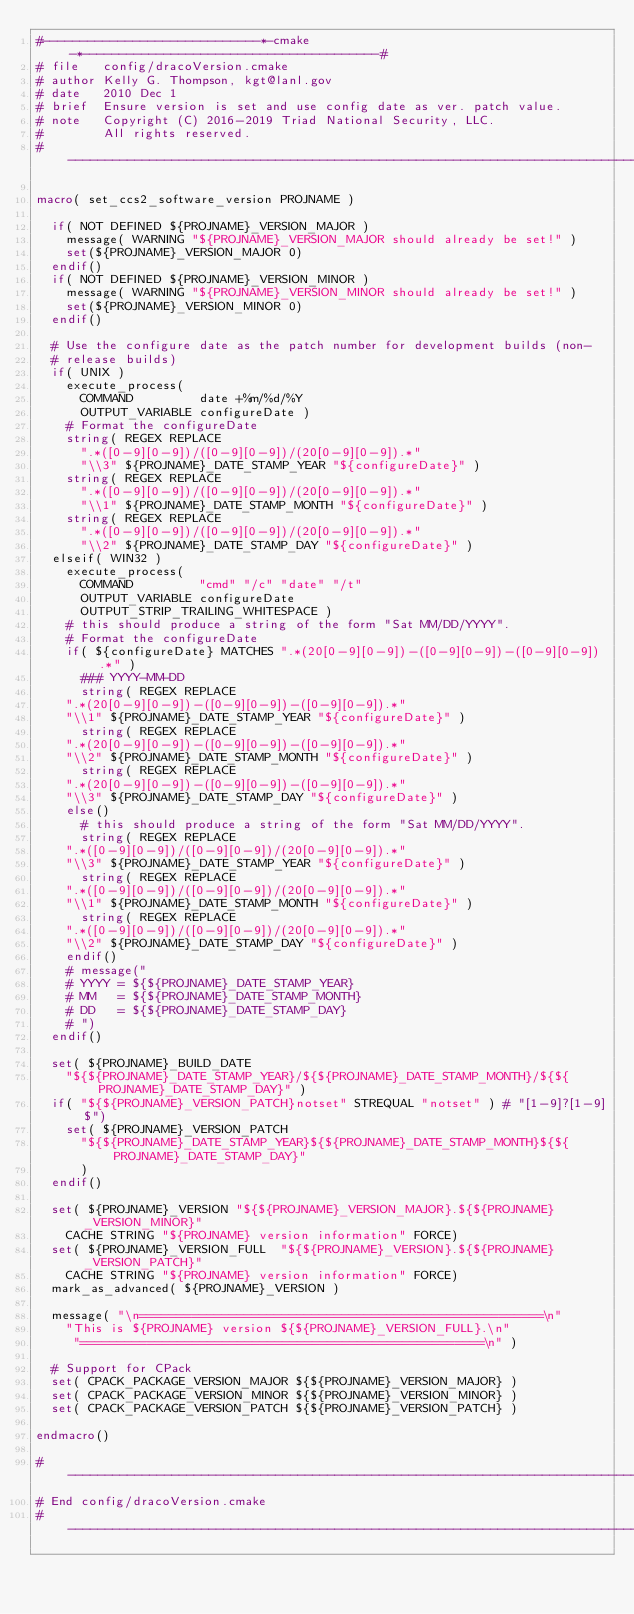Convert code to text. <code><loc_0><loc_0><loc_500><loc_500><_CMake_>#-----------------------------*-cmake-*----------------------------------------#
# file   config/dracoVersion.cmake
# author Kelly G. Thompson, kgt@lanl.gov
# date   2010 Dec 1
# brief  Ensure version is set and use config date as ver. patch value.
# note   Copyright (C) 2016-2019 Triad National Security, LLC.
#        All rights reserved.
#------------------------------------------------------------------------------#

macro( set_ccs2_software_version PROJNAME )

  if( NOT DEFINED ${PROJNAME}_VERSION_MAJOR )
    message( WARNING "${PROJNAME}_VERSION_MAJOR should already be set!" )
    set(${PROJNAME}_VERSION_MAJOR 0)
  endif()
  if( NOT DEFINED ${PROJNAME}_VERSION_MINOR )
    message( WARNING "${PROJNAME}_VERSION_MINOR should already be set!" )
    set(${PROJNAME}_VERSION_MINOR 0)
  endif()

  # Use the configure date as the patch number for development builds (non-
  # release builds)
  if( UNIX )
    execute_process(
      COMMAND         date +%m/%d/%Y
      OUTPUT_VARIABLE configureDate )
    # Format the configureDate
    string( REGEX REPLACE
      ".*([0-9][0-9])/([0-9][0-9])/(20[0-9][0-9]).*"
      "\\3" ${PROJNAME}_DATE_STAMP_YEAR "${configureDate}" )
    string( REGEX REPLACE
      ".*([0-9][0-9])/([0-9][0-9])/(20[0-9][0-9]).*"
      "\\1" ${PROJNAME}_DATE_STAMP_MONTH "${configureDate}" )
    string( REGEX REPLACE
      ".*([0-9][0-9])/([0-9][0-9])/(20[0-9][0-9]).*"
      "\\2" ${PROJNAME}_DATE_STAMP_DAY "${configureDate}" )
  elseif( WIN32 )
    execute_process(
      COMMAND         "cmd" "/c" "date" "/t"
      OUTPUT_VARIABLE configureDate
      OUTPUT_STRIP_TRAILING_WHITESPACE )
    # this should produce a string of the form "Sat MM/DD/YYYY".
    # Format the configureDate
    if( ${configureDate} MATCHES ".*(20[0-9][0-9])-([0-9][0-9])-([0-9][0-9]).*" )
      ### YYYY-MM-DD
      string( REGEX REPLACE
	".*(20[0-9][0-9])-([0-9][0-9])-([0-9][0-9]).*"
	"\\1" ${PROJNAME}_DATE_STAMP_YEAR "${configureDate}" )
      string( REGEX REPLACE
	".*(20[0-9][0-9])-([0-9][0-9])-([0-9][0-9]).*"
	"\\2" ${PROJNAME}_DATE_STAMP_MONTH "${configureDate}" )
      string( REGEX REPLACE
	".*(20[0-9][0-9])-([0-9][0-9])-([0-9][0-9]).*"
	"\\3" ${PROJNAME}_DATE_STAMP_DAY "${configureDate}" )
    else()
      # this should produce a string of the form "Sat MM/DD/YYYY".
      string( REGEX REPLACE
	".*([0-9][0-9])/([0-9][0-9])/(20[0-9][0-9]).*"
	"\\3" ${PROJNAME}_DATE_STAMP_YEAR "${configureDate}" )
      string( REGEX REPLACE
	".*([0-9][0-9])/([0-9][0-9])/(20[0-9][0-9]).*"
	"\\1" ${PROJNAME}_DATE_STAMP_MONTH "${configureDate}" )
      string( REGEX REPLACE
	".*([0-9][0-9])/([0-9][0-9])/(20[0-9][0-9]).*"
	"\\2" ${PROJNAME}_DATE_STAMP_DAY "${configureDate}" )
    endif()
    # message("
    # YYYY = ${${PROJNAME}_DATE_STAMP_YEAR}
    # MM   = ${${PROJNAME}_DATE_STAMP_MONTH}
    # DD   = ${${PROJNAME}_DATE_STAMP_DAY}
    # ")
  endif()

  set( ${PROJNAME}_BUILD_DATE
    "${${PROJNAME}_DATE_STAMP_YEAR}/${${PROJNAME}_DATE_STAMP_MONTH}/${${PROJNAME}_DATE_STAMP_DAY}" )
  if( "${${PROJNAME}_VERSION_PATCH}notset" STREQUAL "notset" ) # "[1-9]?[1-9]$")
    set( ${PROJNAME}_VERSION_PATCH
      "${${PROJNAME}_DATE_STAMP_YEAR}${${PROJNAME}_DATE_STAMP_MONTH}${${PROJNAME}_DATE_STAMP_DAY}"
      )
  endif()

  set( ${PROJNAME}_VERSION "${${PROJNAME}_VERSION_MAJOR}.${${PROJNAME}_VERSION_MINOR}"
    CACHE STRING "${PROJNAME} version information" FORCE)
  set( ${PROJNAME}_VERSION_FULL  "${${PROJNAME}_VERSION}.${${PROJNAME}_VERSION_PATCH}"
    CACHE STRING "${PROJNAME} version information" FORCE)
  mark_as_advanced( ${PROJNAME}_VERSION )

  message( "\n======================================================\n"
    "This is ${PROJNAME} version ${${PROJNAME}_VERSION_FULL}.\n"
     "======================================================\n" )

  # Support for CPack
  set( CPACK_PACKAGE_VERSION_MAJOR ${${PROJNAME}_VERSION_MAJOR} )
  set( CPACK_PACKAGE_VERSION_MINOR ${${PROJNAME}_VERSION_MINOR} )
  set( CPACK_PACKAGE_VERSION_PATCH ${${PROJNAME}_VERSION_PATCH} )

endmacro()

#------------------------------------------------------------------------------#
# End config/dracoVersion.cmake
#------------------------------------------------------------------------------#
</code> 